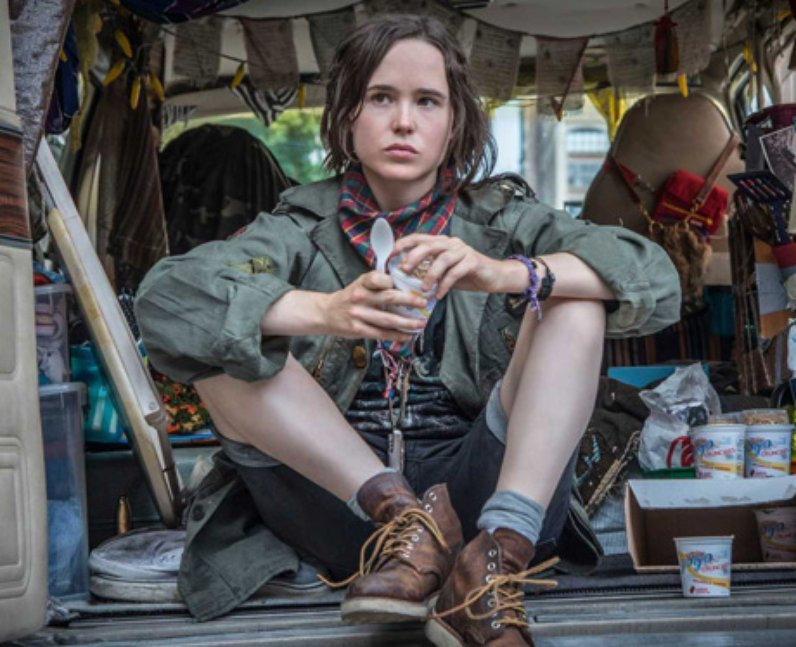If you were to paint this scene, how would you enhance it to convey a deeper story? If I were to paint this scene, I would enhance it by adding elements that hint at the person’s past journeys and future dreams. I might include a map with various destinations marked, pinned to the van wall. The objects surrounding them would have more personal touches—photographs, postcards, and trinkets from different places they've visited. I would use warm, inviting colors to emphasize the coziness of the space, juxtaposed with the vibrant, dynamic colors of the objects to highlight the rich tapestry of experiences. Light streaming through the van’s windows could symbolize hope and endless possibilities extending beyond the vehicle, inviting viewers to wonder about the stories behind this traveling soul. 